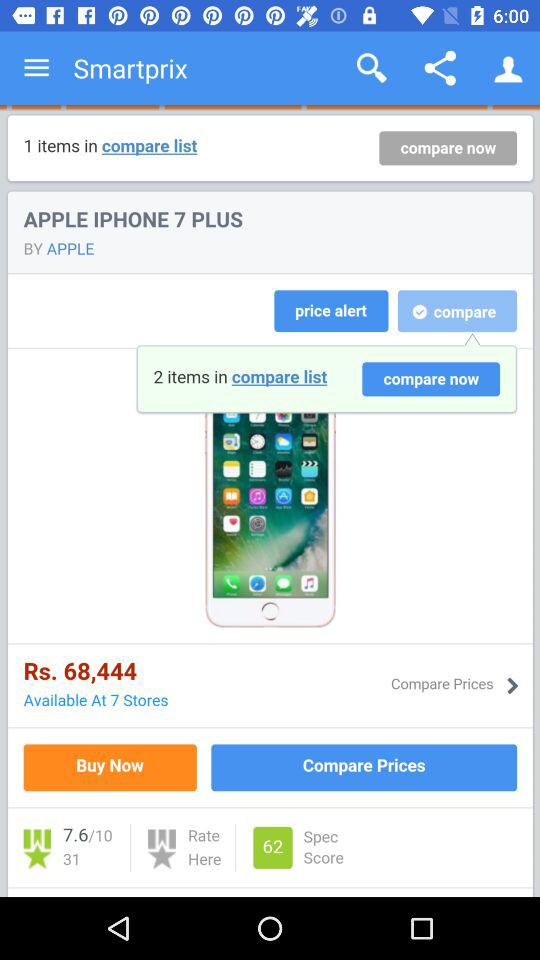How many spec scores are there on the screen? There are 62 spec scores. 